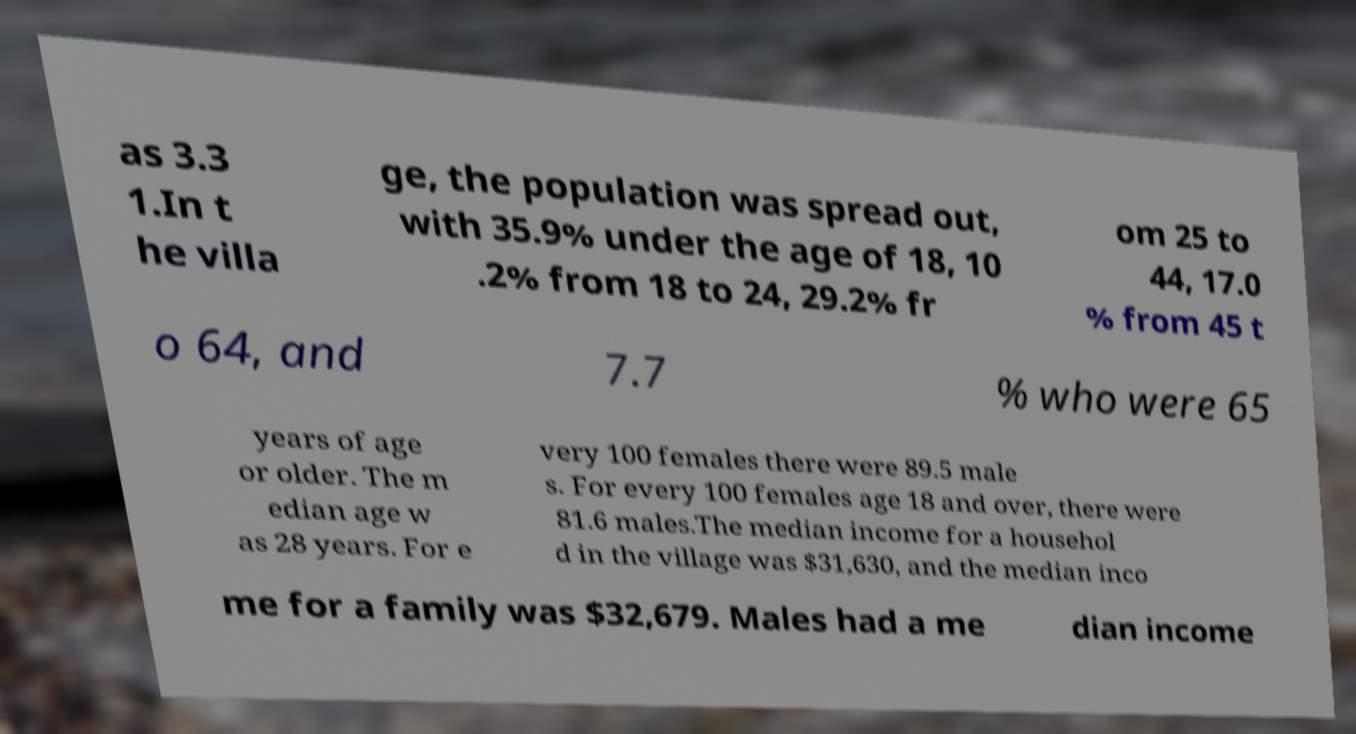Can you accurately transcribe the text from the provided image for me? as 3.3 1.In t he villa ge, the population was spread out, with 35.9% under the age of 18, 10 .2% from 18 to 24, 29.2% fr om 25 to 44, 17.0 % from 45 t o 64, and 7.7 % who were 65 years of age or older. The m edian age w as 28 years. For e very 100 females there were 89.5 male s. For every 100 females age 18 and over, there were 81.6 males.The median income for a househol d in the village was $31,630, and the median inco me for a family was $32,679. Males had a me dian income 